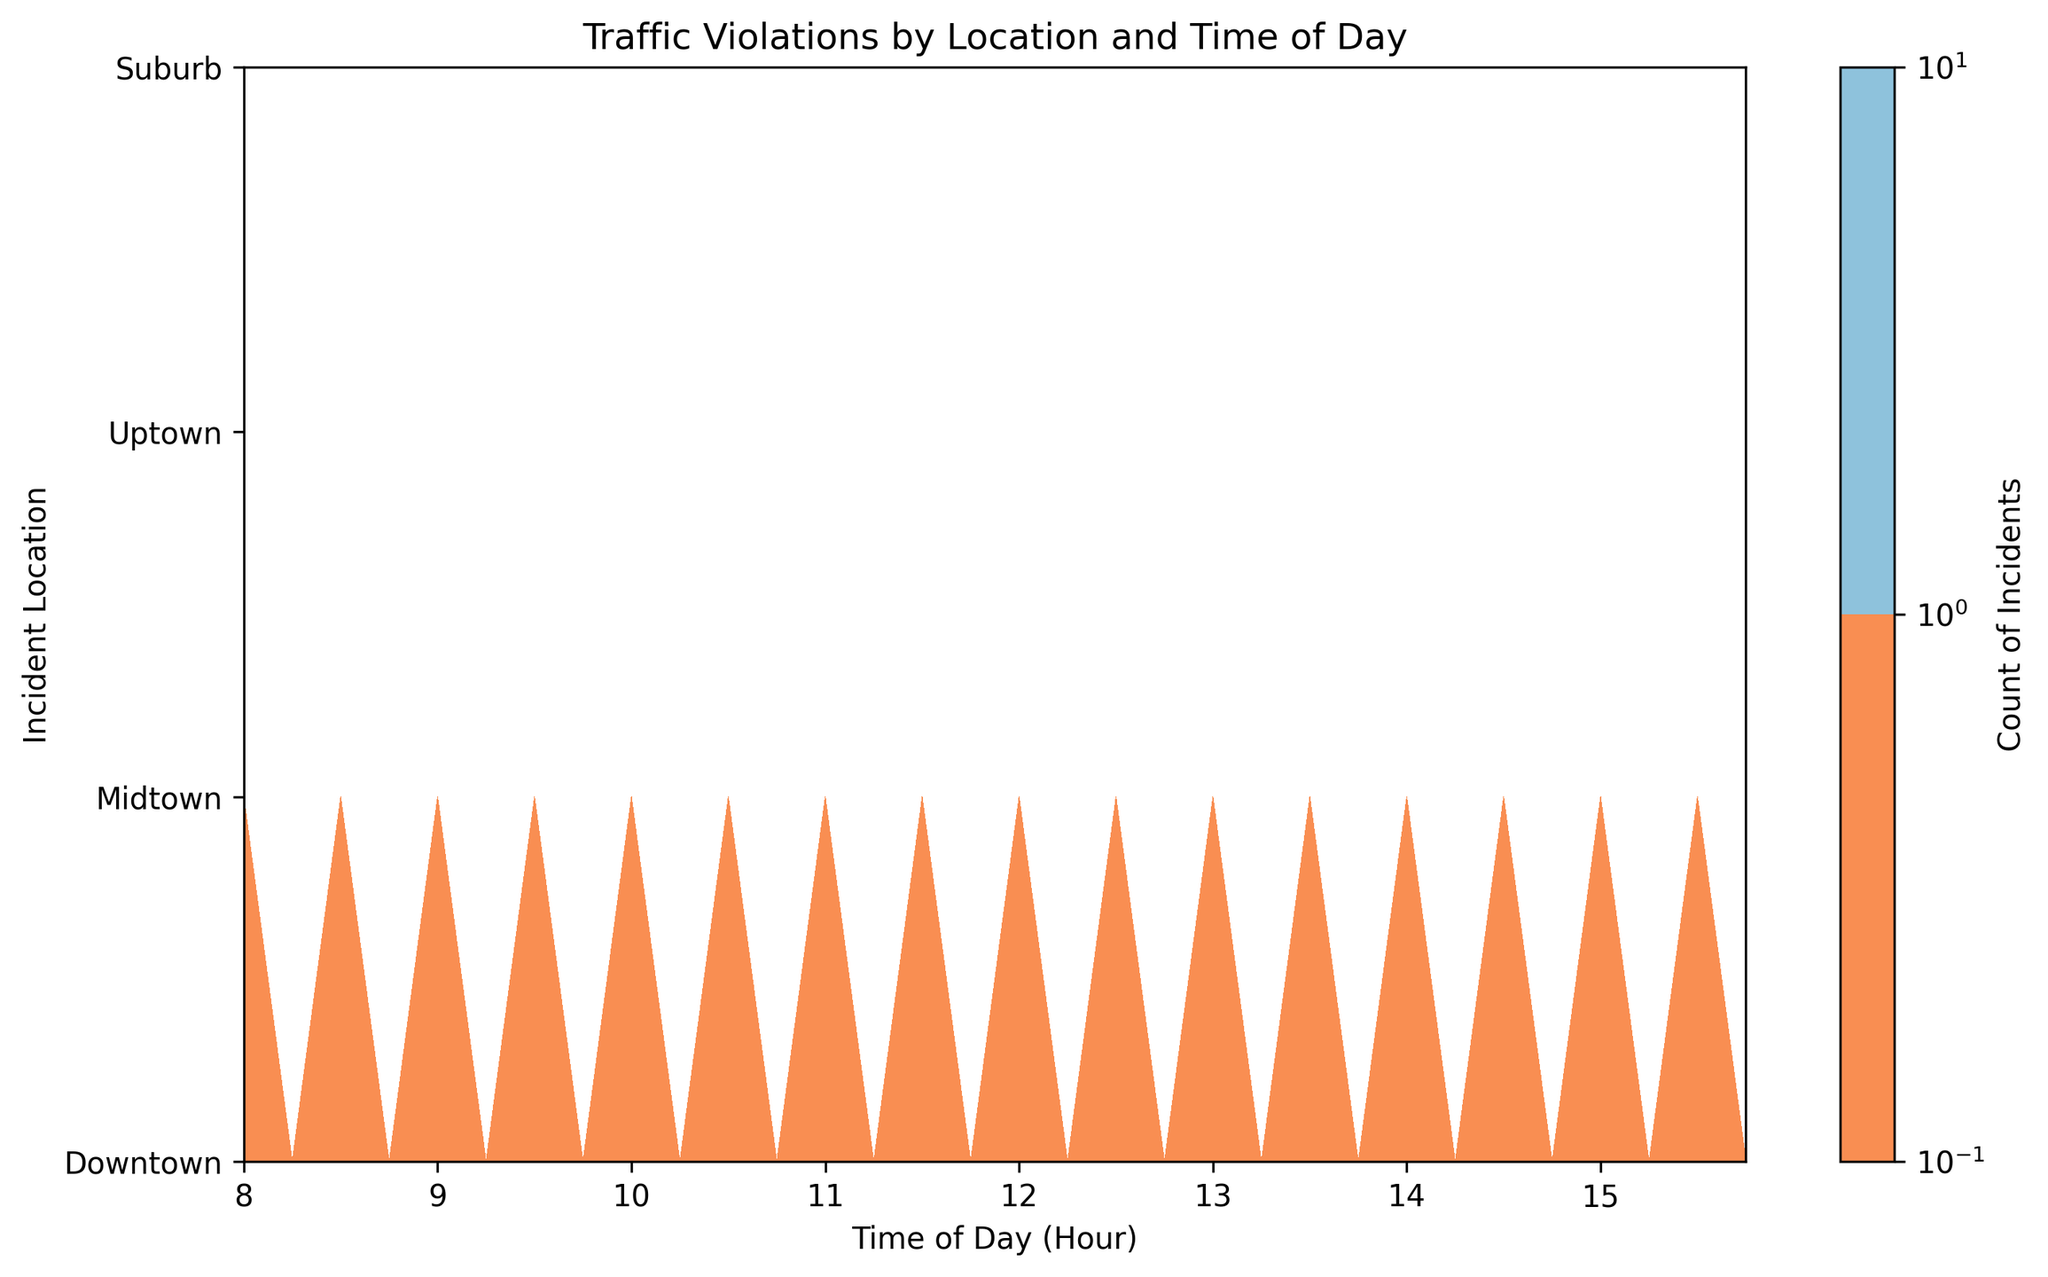Which location has the highest count of traffic violations at 9:00? Look for the highest peaks in the contour at 9:00 across all locations. Downtown shows the highest count at this time.
Answer: Downtown Compare the counts of traffic violations between Midtown and Uptown at 13:00. Find the corresponding places on the contour for Midtown and Uptown at 13:00; the count for Midtown is higher than for Uptown.
Answer: Midtown has more Which times see the highest traffic violations in Downtown? Look at the contour plot for Downtown and identify the time periods with the most prominent color intensity. The highest traffic violations occur around 08:00 and 15:30.
Answer: 08:00 and 15:30 What is the trend of traffic violations in Suburb throughout the day? Observe the color intensity spread in Suburb. The contour shows lower intensity, which suggests a trend of fewer traffic violations throughout the day compared to other locations.
Answer: Generally low How do the peak traffic violation times in Downtown compare to those in Midtown? Examine the time slots with the highest intensity for both Downtown and Midtown. Downtown peaks in the morning and late afternoon, whereas Midtown peaks are more steady throughout the day.
Answer: Downtown peaks in the morning and afternoon, Midtown's steady How does the average count of violations in Uptown compare to the average in Suburb? Sum the values in Uptown and Suburb, then divide by the number of observations in each. Uptown generally has higher counts of violations compared to Suburb which has fewer, flatter peaks.
Answer: Uptown has a higher average During which time can we see the smallest count of violations across all locations? Identify the areas with the least color intensity across all time periods and locations. The lightest areas appear around 11:30 to 13:00.
Answer: 11:30 to 13:00 Which location has the most consistent number of violations throughout the day? Look for even color distribution across the hours for each location. Midtown shows a more consistent pattern throughout the day with steady counts.
Answer: Midtown Calculate the overall peak time for incidents across all locations. Combine and observe the most intense colors across all locations to determine peak times. The overall peak time is close to 08:00 and 15:30.
Answer: 08:00 and 15:30 What are the typical traffic violation patterns in the Suburb? Look closely at the contours in the Suburb region. The violations are sparse, occurring mainly at specific times such as around 08:30 and 14:30.
Answer: Sparse and specific times 